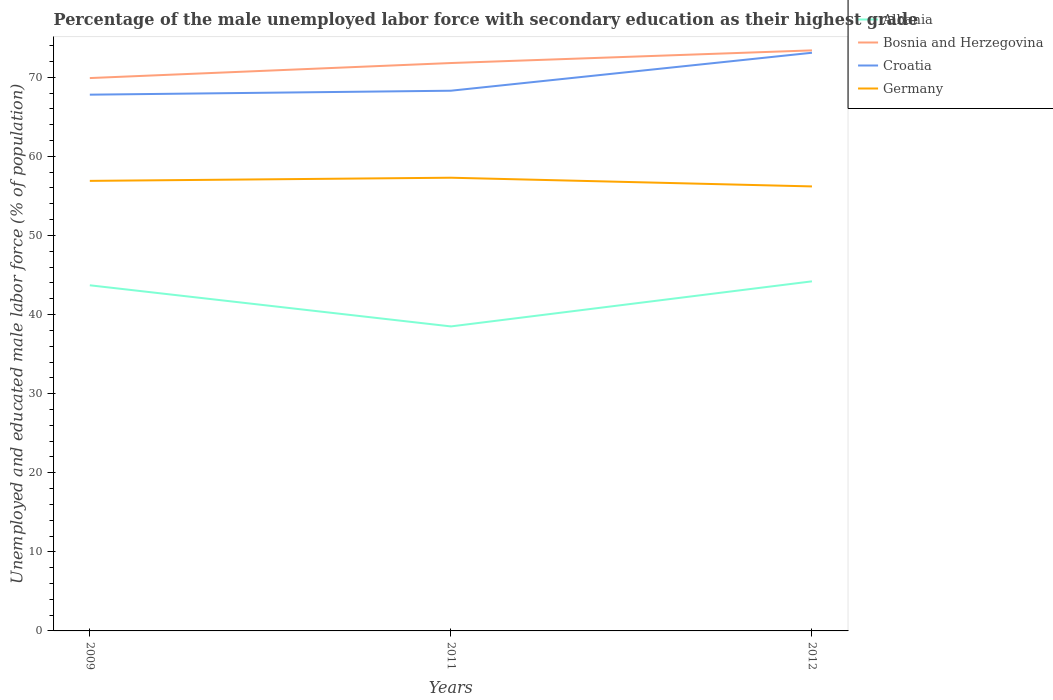How many different coloured lines are there?
Give a very brief answer. 4. Is the number of lines equal to the number of legend labels?
Keep it short and to the point. Yes. Across all years, what is the maximum percentage of the unemployed male labor force with secondary education in Bosnia and Herzegovina?
Keep it short and to the point. 69.9. What is the total percentage of the unemployed male labor force with secondary education in Bosnia and Herzegovina in the graph?
Give a very brief answer. -1.9. What is the difference between the highest and the second highest percentage of the unemployed male labor force with secondary education in Croatia?
Provide a short and direct response. 5.3. What is the difference between the highest and the lowest percentage of the unemployed male labor force with secondary education in Bosnia and Herzegovina?
Give a very brief answer. 2. Is the percentage of the unemployed male labor force with secondary education in Germany strictly greater than the percentage of the unemployed male labor force with secondary education in Bosnia and Herzegovina over the years?
Offer a very short reply. Yes. How many years are there in the graph?
Make the answer very short. 3. Does the graph contain grids?
Ensure brevity in your answer.  No. How many legend labels are there?
Your response must be concise. 4. How are the legend labels stacked?
Your answer should be very brief. Vertical. What is the title of the graph?
Ensure brevity in your answer.  Percentage of the male unemployed labor force with secondary education as their highest grade. Does "Upper middle income" appear as one of the legend labels in the graph?
Make the answer very short. No. What is the label or title of the X-axis?
Provide a short and direct response. Years. What is the label or title of the Y-axis?
Your answer should be very brief. Unemployed and educated male labor force (% of population). What is the Unemployed and educated male labor force (% of population) of Albania in 2009?
Provide a short and direct response. 43.7. What is the Unemployed and educated male labor force (% of population) of Bosnia and Herzegovina in 2009?
Your response must be concise. 69.9. What is the Unemployed and educated male labor force (% of population) of Croatia in 2009?
Your answer should be very brief. 67.8. What is the Unemployed and educated male labor force (% of population) of Germany in 2009?
Keep it short and to the point. 56.9. What is the Unemployed and educated male labor force (% of population) of Albania in 2011?
Your answer should be compact. 38.5. What is the Unemployed and educated male labor force (% of population) of Bosnia and Herzegovina in 2011?
Your answer should be very brief. 71.8. What is the Unemployed and educated male labor force (% of population) in Croatia in 2011?
Provide a short and direct response. 68.3. What is the Unemployed and educated male labor force (% of population) of Germany in 2011?
Offer a very short reply. 57.3. What is the Unemployed and educated male labor force (% of population) of Albania in 2012?
Your answer should be very brief. 44.2. What is the Unemployed and educated male labor force (% of population) of Bosnia and Herzegovina in 2012?
Provide a short and direct response. 73.4. What is the Unemployed and educated male labor force (% of population) of Croatia in 2012?
Offer a very short reply. 73.1. What is the Unemployed and educated male labor force (% of population) in Germany in 2012?
Offer a very short reply. 56.2. Across all years, what is the maximum Unemployed and educated male labor force (% of population) of Albania?
Offer a terse response. 44.2. Across all years, what is the maximum Unemployed and educated male labor force (% of population) in Bosnia and Herzegovina?
Offer a terse response. 73.4. Across all years, what is the maximum Unemployed and educated male labor force (% of population) of Croatia?
Your answer should be compact. 73.1. Across all years, what is the maximum Unemployed and educated male labor force (% of population) of Germany?
Make the answer very short. 57.3. Across all years, what is the minimum Unemployed and educated male labor force (% of population) in Albania?
Give a very brief answer. 38.5. Across all years, what is the minimum Unemployed and educated male labor force (% of population) of Bosnia and Herzegovina?
Offer a terse response. 69.9. Across all years, what is the minimum Unemployed and educated male labor force (% of population) of Croatia?
Ensure brevity in your answer.  67.8. Across all years, what is the minimum Unemployed and educated male labor force (% of population) of Germany?
Give a very brief answer. 56.2. What is the total Unemployed and educated male labor force (% of population) of Albania in the graph?
Your response must be concise. 126.4. What is the total Unemployed and educated male labor force (% of population) of Bosnia and Herzegovina in the graph?
Offer a very short reply. 215.1. What is the total Unemployed and educated male labor force (% of population) of Croatia in the graph?
Provide a succinct answer. 209.2. What is the total Unemployed and educated male labor force (% of population) of Germany in the graph?
Give a very brief answer. 170.4. What is the difference between the Unemployed and educated male labor force (% of population) of Albania in 2009 and that in 2011?
Keep it short and to the point. 5.2. What is the difference between the Unemployed and educated male labor force (% of population) of Bosnia and Herzegovina in 2009 and that in 2011?
Offer a terse response. -1.9. What is the difference between the Unemployed and educated male labor force (% of population) in Croatia in 2009 and that in 2011?
Give a very brief answer. -0.5. What is the difference between the Unemployed and educated male labor force (% of population) of Germany in 2009 and that in 2011?
Your response must be concise. -0.4. What is the difference between the Unemployed and educated male labor force (% of population) in Albania in 2009 and that in 2012?
Make the answer very short. -0.5. What is the difference between the Unemployed and educated male labor force (% of population) of Germany in 2009 and that in 2012?
Make the answer very short. 0.7. What is the difference between the Unemployed and educated male labor force (% of population) in Albania in 2011 and that in 2012?
Your response must be concise. -5.7. What is the difference between the Unemployed and educated male labor force (% of population) of Germany in 2011 and that in 2012?
Your answer should be compact. 1.1. What is the difference between the Unemployed and educated male labor force (% of population) in Albania in 2009 and the Unemployed and educated male labor force (% of population) in Bosnia and Herzegovina in 2011?
Make the answer very short. -28.1. What is the difference between the Unemployed and educated male labor force (% of population) of Albania in 2009 and the Unemployed and educated male labor force (% of population) of Croatia in 2011?
Your answer should be compact. -24.6. What is the difference between the Unemployed and educated male labor force (% of population) in Bosnia and Herzegovina in 2009 and the Unemployed and educated male labor force (% of population) in Germany in 2011?
Your answer should be very brief. 12.6. What is the difference between the Unemployed and educated male labor force (% of population) in Croatia in 2009 and the Unemployed and educated male labor force (% of population) in Germany in 2011?
Keep it short and to the point. 10.5. What is the difference between the Unemployed and educated male labor force (% of population) of Albania in 2009 and the Unemployed and educated male labor force (% of population) of Bosnia and Herzegovina in 2012?
Offer a terse response. -29.7. What is the difference between the Unemployed and educated male labor force (% of population) in Albania in 2009 and the Unemployed and educated male labor force (% of population) in Croatia in 2012?
Provide a succinct answer. -29.4. What is the difference between the Unemployed and educated male labor force (% of population) of Albania in 2009 and the Unemployed and educated male labor force (% of population) of Germany in 2012?
Provide a succinct answer. -12.5. What is the difference between the Unemployed and educated male labor force (% of population) in Bosnia and Herzegovina in 2009 and the Unemployed and educated male labor force (% of population) in Croatia in 2012?
Offer a very short reply. -3.2. What is the difference between the Unemployed and educated male labor force (% of population) of Albania in 2011 and the Unemployed and educated male labor force (% of population) of Bosnia and Herzegovina in 2012?
Make the answer very short. -34.9. What is the difference between the Unemployed and educated male labor force (% of population) in Albania in 2011 and the Unemployed and educated male labor force (% of population) in Croatia in 2012?
Your answer should be very brief. -34.6. What is the difference between the Unemployed and educated male labor force (% of population) of Albania in 2011 and the Unemployed and educated male labor force (% of population) of Germany in 2012?
Ensure brevity in your answer.  -17.7. What is the difference between the Unemployed and educated male labor force (% of population) of Bosnia and Herzegovina in 2011 and the Unemployed and educated male labor force (% of population) of Germany in 2012?
Your answer should be compact. 15.6. What is the average Unemployed and educated male labor force (% of population) of Albania per year?
Provide a short and direct response. 42.13. What is the average Unemployed and educated male labor force (% of population) of Bosnia and Herzegovina per year?
Your response must be concise. 71.7. What is the average Unemployed and educated male labor force (% of population) in Croatia per year?
Keep it short and to the point. 69.73. What is the average Unemployed and educated male labor force (% of population) of Germany per year?
Your answer should be compact. 56.8. In the year 2009, what is the difference between the Unemployed and educated male labor force (% of population) in Albania and Unemployed and educated male labor force (% of population) in Bosnia and Herzegovina?
Your answer should be very brief. -26.2. In the year 2009, what is the difference between the Unemployed and educated male labor force (% of population) in Albania and Unemployed and educated male labor force (% of population) in Croatia?
Ensure brevity in your answer.  -24.1. In the year 2009, what is the difference between the Unemployed and educated male labor force (% of population) in Bosnia and Herzegovina and Unemployed and educated male labor force (% of population) in Germany?
Make the answer very short. 13. In the year 2011, what is the difference between the Unemployed and educated male labor force (% of population) of Albania and Unemployed and educated male labor force (% of population) of Bosnia and Herzegovina?
Offer a terse response. -33.3. In the year 2011, what is the difference between the Unemployed and educated male labor force (% of population) in Albania and Unemployed and educated male labor force (% of population) in Croatia?
Your response must be concise. -29.8. In the year 2011, what is the difference between the Unemployed and educated male labor force (% of population) in Albania and Unemployed and educated male labor force (% of population) in Germany?
Offer a very short reply. -18.8. In the year 2011, what is the difference between the Unemployed and educated male labor force (% of population) of Croatia and Unemployed and educated male labor force (% of population) of Germany?
Make the answer very short. 11. In the year 2012, what is the difference between the Unemployed and educated male labor force (% of population) of Albania and Unemployed and educated male labor force (% of population) of Bosnia and Herzegovina?
Offer a very short reply. -29.2. In the year 2012, what is the difference between the Unemployed and educated male labor force (% of population) of Albania and Unemployed and educated male labor force (% of population) of Croatia?
Offer a terse response. -28.9. In the year 2012, what is the difference between the Unemployed and educated male labor force (% of population) in Bosnia and Herzegovina and Unemployed and educated male labor force (% of population) in Germany?
Offer a very short reply. 17.2. In the year 2012, what is the difference between the Unemployed and educated male labor force (% of population) in Croatia and Unemployed and educated male labor force (% of population) in Germany?
Give a very brief answer. 16.9. What is the ratio of the Unemployed and educated male labor force (% of population) of Albania in 2009 to that in 2011?
Your answer should be compact. 1.14. What is the ratio of the Unemployed and educated male labor force (% of population) in Bosnia and Herzegovina in 2009 to that in 2011?
Provide a succinct answer. 0.97. What is the ratio of the Unemployed and educated male labor force (% of population) of Albania in 2009 to that in 2012?
Offer a very short reply. 0.99. What is the ratio of the Unemployed and educated male labor force (% of population) of Bosnia and Herzegovina in 2009 to that in 2012?
Offer a very short reply. 0.95. What is the ratio of the Unemployed and educated male labor force (% of population) of Croatia in 2009 to that in 2012?
Give a very brief answer. 0.93. What is the ratio of the Unemployed and educated male labor force (% of population) in Germany in 2009 to that in 2012?
Keep it short and to the point. 1.01. What is the ratio of the Unemployed and educated male labor force (% of population) of Albania in 2011 to that in 2012?
Give a very brief answer. 0.87. What is the ratio of the Unemployed and educated male labor force (% of population) in Bosnia and Herzegovina in 2011 to that in 2012?
Your response must be concise. 0.98. What is the ratio of the Unemployed and educated male labor force (% of population) of Croatia in 2011 to that in 2012?
Offer a very short reply. 0.93. What is the ratio of the Unemployed and educated male labor force (% of population) of Germany in 2011 to that in 2012?
Your answer should be very brief. 1.02. What is the difference between the highest and the second highest Unemployed and educated male labor force (% of population) of Albania?
Provide a short and direct response. 0.5. What is the difference between the highest and the second highest Unemployed and educated male labor force (% of population) in Bosnia and Herzegovina?
Make the answer very short. 1.6. What is the difference between the highest and the second highest Unemployed and educated male labor force (% of population) in Germany?
Give a very brief answer. 0.4. What is the difference between the highest and the lowest Unemployed and educated male labor force (% of population) of Bosnia and Herzegovina?
Your answer should be very brief. 3.5. What is the difference between the highest and the lowest Unemployed and educated male labor force (% of population) in Croatia?
Keep it short and to the point. 5.3. 